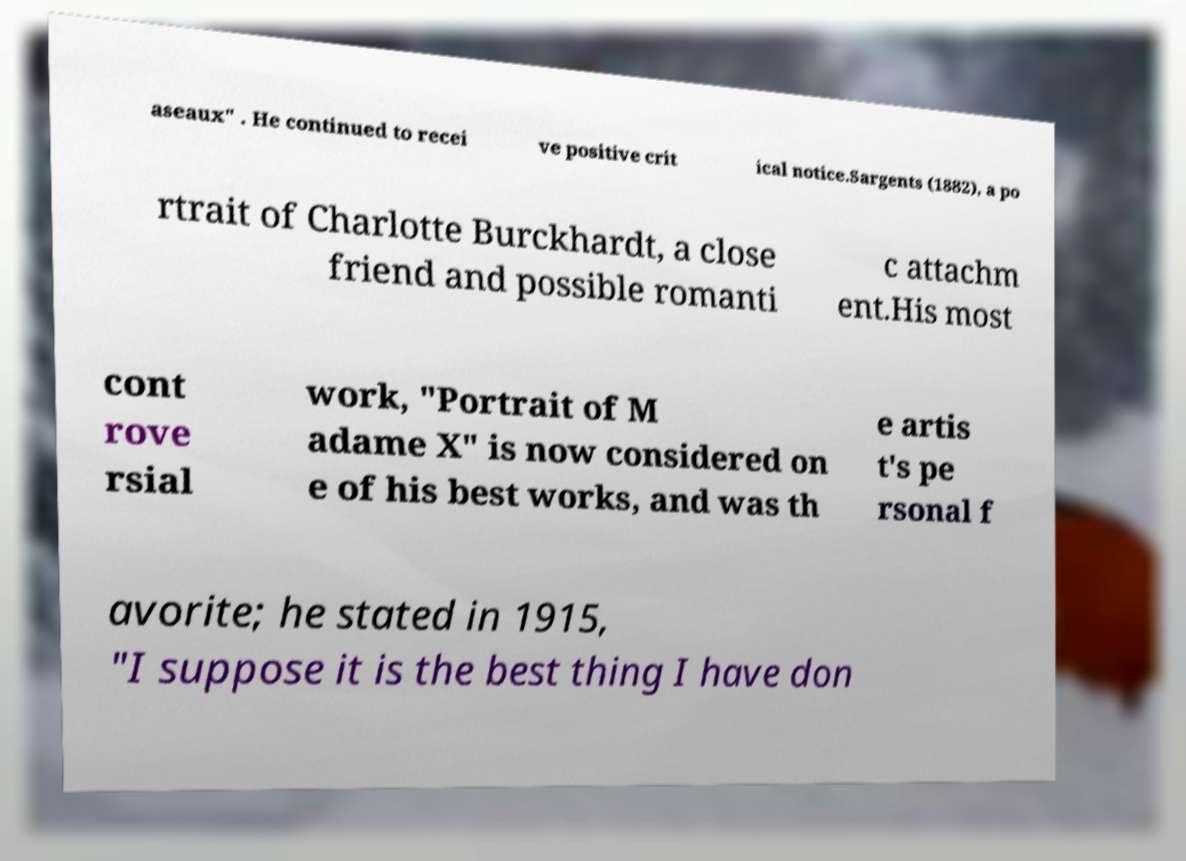What messages or text are displayed in this image? I need them in a readable, typed format. aseaux" . He continued to recei ve positive crit ical notice.Sargents (1882), a po rtrait of Charlotte Burckhardt, a close friend and possible romanti c attachm ent.His most cont rove rsial work, "Portrait of M adame X" is now considered on e of his best works, and was th e artis t's pe rsonal f avorite; he stated in 1915, "I suppose it is the best thing I have don 